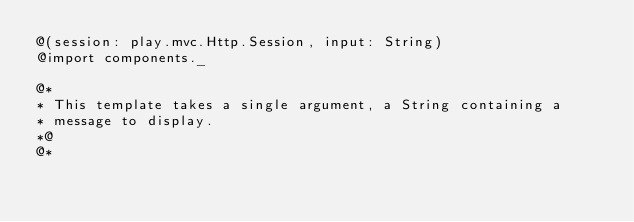<code> <loc_0><loc_0><loc_500><loc_500><_HTML_>@(session: play.mvc.Http.Session, input: String)
@import components._

@*
* This template takes a single argument, a String containing a
* message to display.
*@
@*</code> 